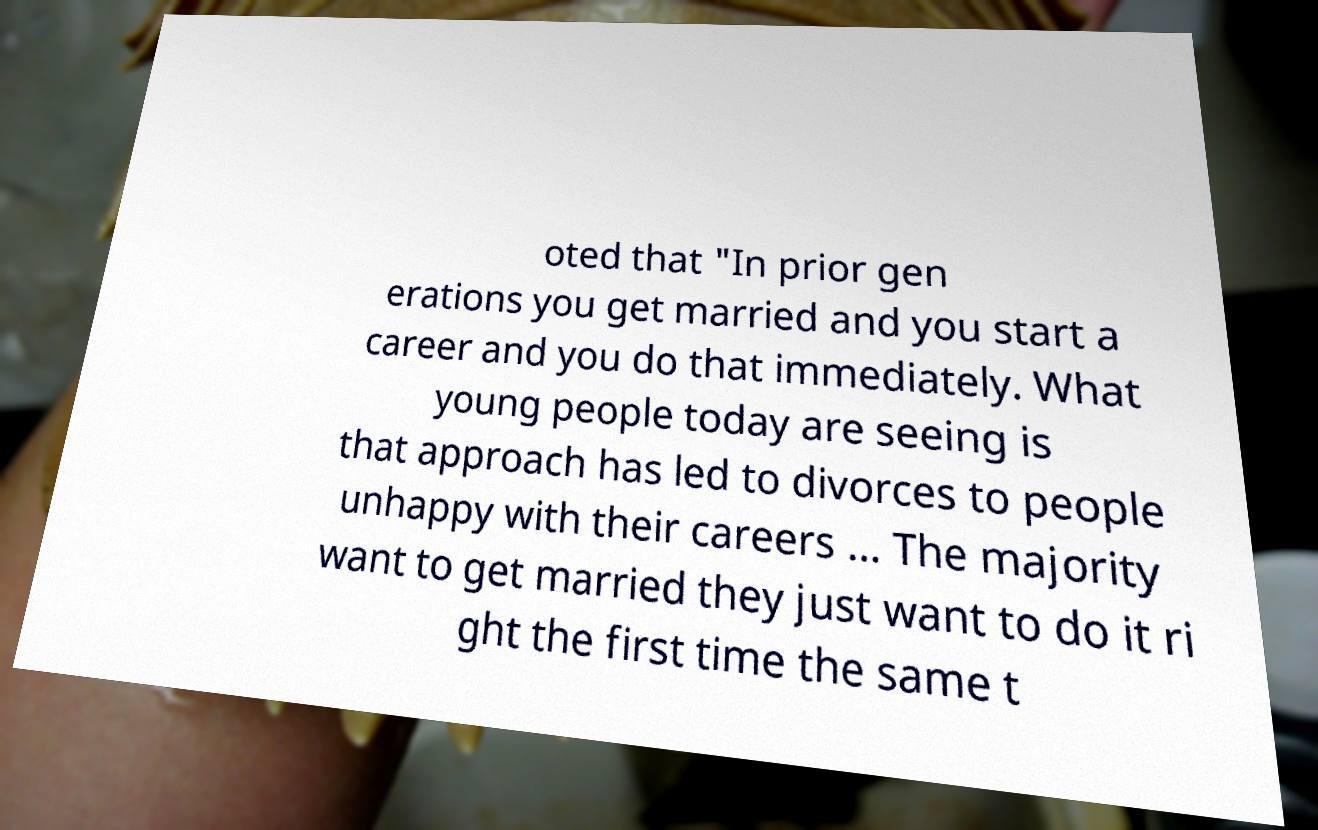Could you extract and type out the text from this image? oted that "In prior gen erations you get married and you start a career and you do that immediately. What young people today are seeing is that approach has led to divorces to people unhappy with their careers … The majority want to get married they just want to do it ri ght the first time the same t 